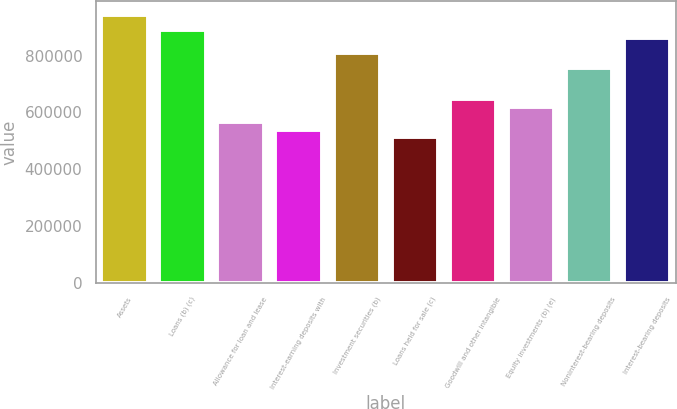Convert chart. <chart><loc_0><loc_0><loc_500><loc_500><bar_chart><fcel>Assets<fcel>Loans (b) (c)<fcel>Allowance for loan and lease<fcel>Interest-earning deposits with<fcel>Investment securities (b)<fcel>Loans held for sale (c)<fcel>Goodwill and other intangible<fcel>Equity investments (b) (e)<fcel>Noninterest-bearing deposits<fcel>Interest-bearing deposits<nl><fcel>944518<fcel>890546<fcel>566711<fcel>539725<fcel>809587<fcel>512739<fcel>647670<fcel>620684<fcel>755615<fcel>863560<nl></chart> 